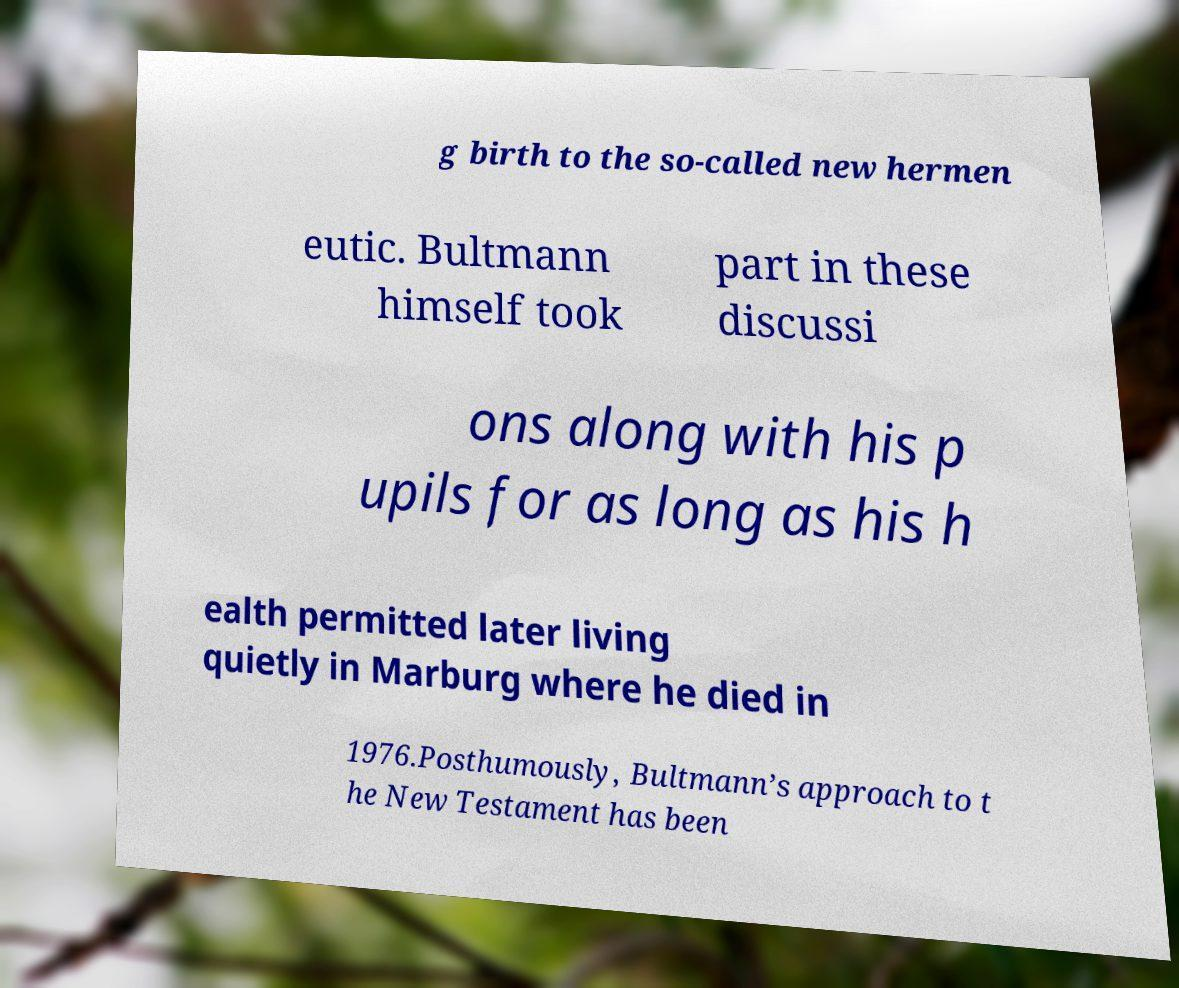Please identify and transcribe the text found in this image. g birth to the so-called new hermen eutic. Bultmann himself took part in these discussi ons along with his p upils for as long as his h ealth permitted later living quietly in Marburg where he died in 1976.Posthumously, Bultmann’s approach to t he New Testament has been 